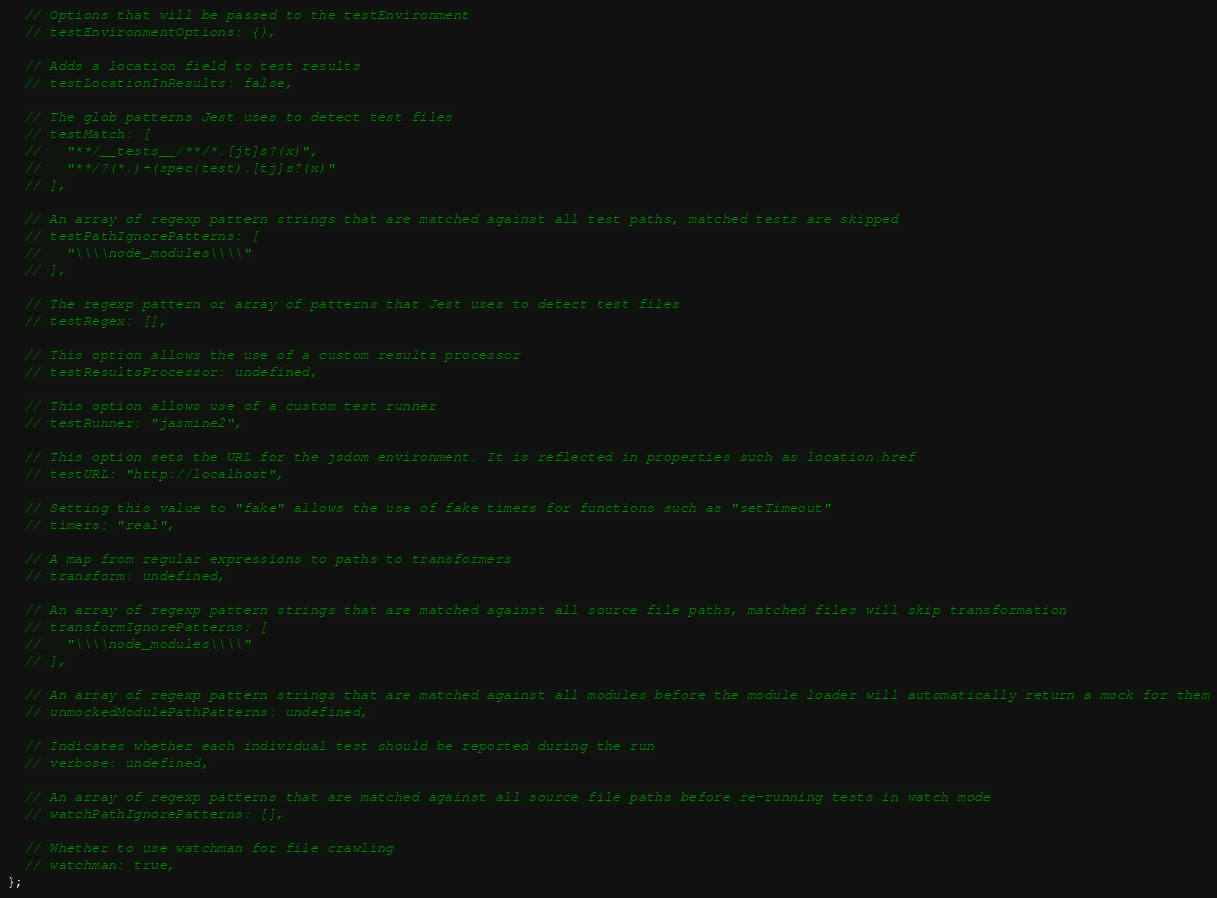Convert code to text. <code><loc_0><loc_0><loc_500><loc_500><_JavaScript_>  // Options that will be passed to the testEnvironment
  // testEnvironmentOptions: {},

  // Adds a location field to test results
  // testLocationInResults: false,

  // The glob patterns Jest uses to detect test files
  // testMatch: [
  //   "**/__tests__/**/*.[jt]s?(x)",
  //   "**/?(*.)+(spec|test).[tj]s?(x)"
  // ],

  // An array of regexp pattern strings that are matched against all test paths, matched tests are skipped
  // testPathIgnorePatterns: [
  //   "\\\\node_modules\\\\"
  // ],

  // The regexp pattern or array of patterns that Jest uses to detect test files
  // testRegex: [],

  // This option allows the use of a custom results processor
  // testResultsProcessor: undefined,

  // This option allows use of a custom test runner
  // testRunner: "jasmine2",

  // This option sets the URL for the jsdom environment. It is reflected in properties such as location.href
  // testURL: "http://localhost",

  // Setting this value to "fake" allows the use of fake timers for functions such as "setTimeout"
  // timers: "real",

  // A map from regular expressions to paths to transformers
  // transform: undefined,

  // An array of regexp pattern strings that are matched against all source file paths, matched files will skip transformation
  // transformIgnorePatterns: [
  //   "\\\\node_modules\\\\"
  // ],

  // An array of regexp pattern strings that are matched against all modules before the module loader will automatically return a mock for them
  // unmockedModulePathPatterns: undefined,

  // Indicates whether each individual test should be reported during the run
  // verbose: undefined,

  // An array of regexp patterns that are matched against all source file paths before re-running tests in watch mode
  // watchPathIgnorePatterns: [],

  // Whether to use watchman for file crawling
  // watchman: true,
};
</code> 